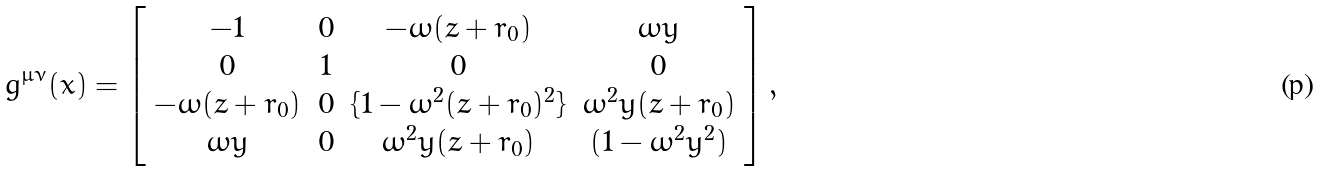Convert formula to latex. <formula><loc_0><loc_0><loc_500><loc_500>g ^ { \mu \nu } ( x ) = \left [ \begin{array} { c c c c } - 1 & 0 & - \omega ( z + r _ { 0 } ) & \omega y \\ 0 & 1 & 0 & 0 \\ - \omega ( z + r _ { 0 } ) & 0 & \{ 1 - \omega ^ { 2 } ( z + r _ { 0 } ) ^ { 2 } \} & \omega ^ { 2 } y ( z + r _ { 0 } ) \\ \omega y & 0 & \omega ^ { 2 } y ( z + r _ { 0 } ) & ( 1 - \omega ^ { 2 } y ^ { 2 } ) \end{array} \right ] ,</formula> 